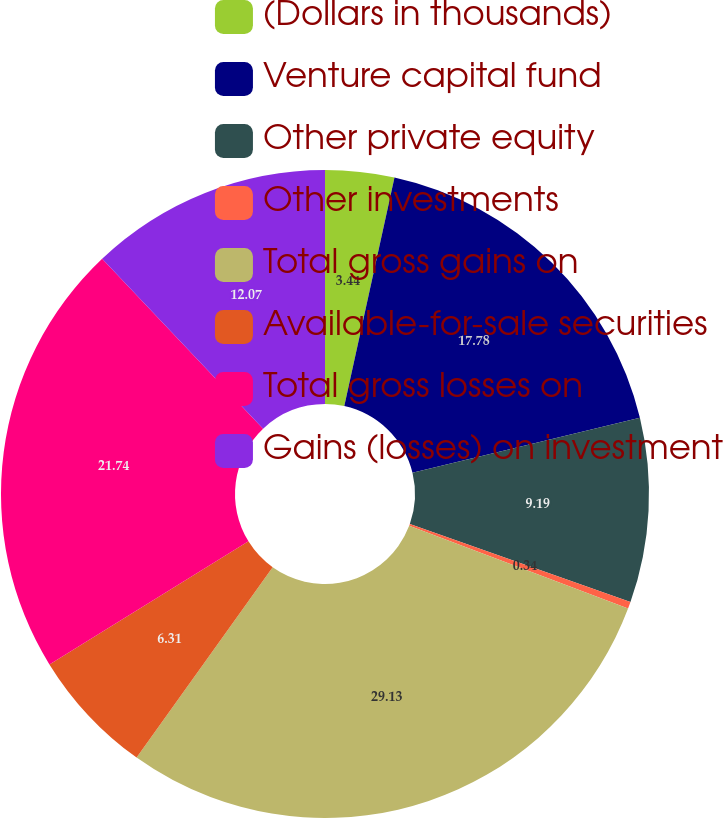<chart> <loc_0><loc_0><loc_500><loc_500><pie_chart><fcel>(Dollars in thousands)<fcel>Venture capital fund<fcel>Other private equity<fcel>Other investments<fcel>Total gross gains on<fcel>Available-for-sale securities<fcel>Total gross losses on<fcel>Gains (losses) on investment<nl><fcel>3.44%<fcel>17.78%<fcel>9.19%<fcel>0.34%<fcel>29.12%<fcel>6.31%<fcel>21.74%<fcel>12.07%<nl></chart> 